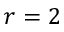Convert formula to latex. <formula><loc_0><loc_0><loc_500><loc_500>r = 2</formula> 